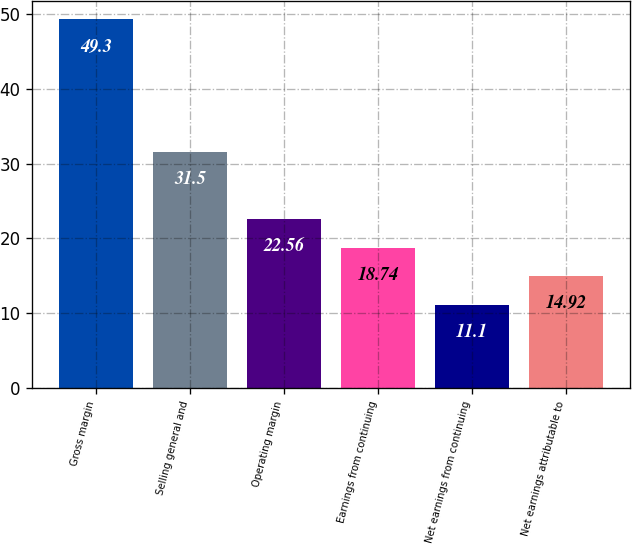<chart> <loc_0><loc_0><loc_500><loc_500><bar_chart><fcel>Gross margin<fcel>Selling general and<fcel>Operating margin<fcel>Earnings from continuing<fcel>Net earnings from continuing<fcel>Net earnings attributable to<nl><fcel>49.3<fcel>31.5<fcel>22.56<fcel>18.74<fcel>11.1<fcel>14.92<nl></chart> 